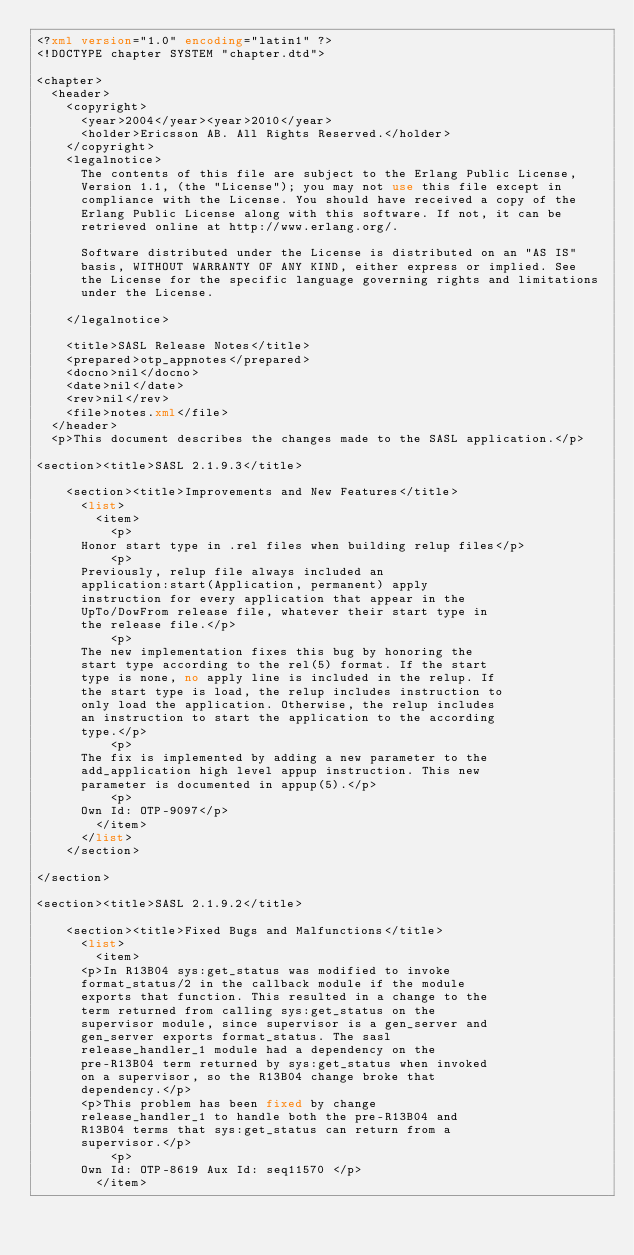<code> <loc_0><loc_0><loc_500><loc_500><_XML_><?xml version="1.0" encoding="latin1" ?>
<!DOCTYPE chapter SYSTEM "chapter.dtd">

<chapter>
  <header>
    <copyright>
      <year>2004</year><year>2010</year>
      <holder>Ericsson AB. All Rights Reserved.</holder>
    </copyright>
    <legalnotice>
      The contents of this file are subject to the Erlang Public License,
      Version 1.1, (the "License"); you may not use this file except in
      compliance with the License. You should have received a copy of the
      Erlang Public License along with this software. If not, it can be
      retrieved online at http://www.erlang.org/.

      Software distributed under the License is distributed on an "AS IS"
      basis, WITHOUT WARRANTY OF ANY KIND, either express or implied. See
      the License for the specific language governing rights and limitations
      under the License.

    </legalnotice>

    <title>SASL Release Notes</title>
    <prepared>otp_appnotes</prepared>
    <docno>nil</docno>
    <date>nil</date>
    <rev>nil</rev>
    <file>notes.xml</file>
  </header>
  <p>This document describes the changes made to the SASL application.</p>

<section><title>SASL 2.1.9.3</title>

    <section><title>Improvements and New Features</title>
      <list>
        <item>
          <p>
	    Honor start type in .rel files when building relup files</p>
          <p>
	    Previously, relup file always included an
	    application:start(Application, permanent) apply
	    instruction for every application that appear in the
	    UpTo/DowFrom release file, whatever their start type in
	    the release file.</p>
          <p>
	    The new implementation fixes this bug by honoring the
	    start type according to the rel(5) format. If the start
	    type is none, no apply line is included in the relup. If
	    the start type is load, the relup includes instruction to
	    only load the application. Otherwise, the relup includes
	    an instruction to start the application to the according
	    type.</p>
          <p>
	    The fix is implemented by adding a new parameter to the
	    add_application high level appup instruction. This new
	    parameter is documented in appup(5).</p>
          <p>
	    Own Id: OTP-9097</p>
        </item>
      </list>
    </section>

</section>

<section><title>SASL 2.1.9.2</title>

    <section><title>Fixed Bugs and Malfunctions</title>
      <list>
        <item>
	    <p>In R13B04 sys:get_status was modified to invoke
	    format_status/2 in the callback module if the module
	    exports that function. This resulted in a change to the
	    term returned from calling sys:get_status on the
	    supervisor module, since supervisor is a gen_server and
	    gen_server exports format_status. The sasl
	    release_handler_1 module had a dependency on the
	    pre-R13B04 term returned by sys:get_status when invoked
	    on a supervisor, so the R13B04 change broke that
	    dependency.</p>
	    <p>This problem has been fixed by change
	    release_handler_1 to handle both the pre-R13B04 and
	    R13B04 terms that sys:get_status can return from a
	    supervisor.</p>
          <p>
	    Own Id: OTP-8619 Aux Id: seq11570 </p>
        </item></code> 